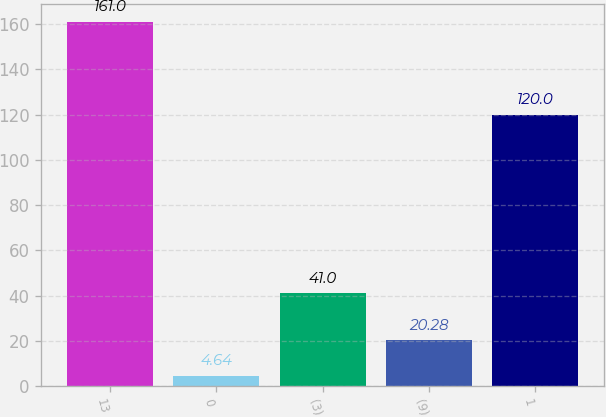<chart> <loc_0><loc_0><loc_500><loc_500><bar_chart><fcel>13<fcel>0<fcel>(3)<fcel>(9)<fcel>1<nl><fcel>161<fcel>4.64<fcel>41<fcel>20.28<fcel>120<nl></chart> 